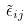<formula> <loc_0><loc_0><loc_500><loc_500>\tilde { \epsilon } _ { i j }</formula> 